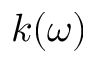<formula> <loc_0><loc_0><loc_500><loc_500>k ( \omega )</formula> 